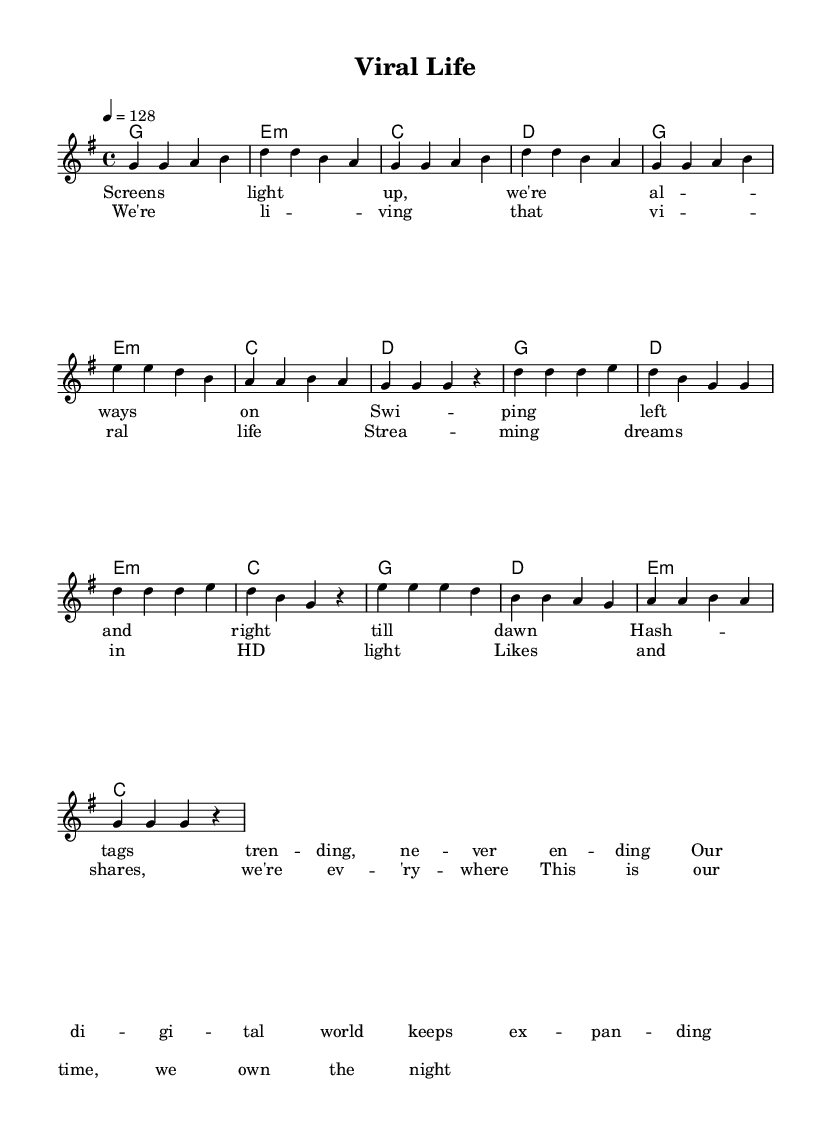What is the key signature of this music? The key signature is G major, which has one sharp (F#). This is indicated at the beginning of the score.
Answer: G major What is the time signature of this music? The time signature is 4/4, which means there are four beats in each measure and the quarter note gets one beat. This is noted at the beginning of the score.
Answer: 4/4 What is the tempo marking of this piece? The tempo marking is 128 beats per minute (BPM). This is provided right after the time signature in the global section.
Answer: 128 How many measures are in the verse? There are eight measures in the verse, as indicated by counting the individual groups of notes and bars in that section of the music.
Answer: Eight What is the first lyric of the chorus? The first lyric of the chorus is "We're living that viral life." This can be seen in the chorus lyrics section following the measure lines.
Answer: "We're living that viral life." What type of chords accompany the chorus? The chorus is accompanied by G, D, E minor, and C chords, as can be seen in the harmonies section of the score under the chorus.
Answer: G, D, E minor, C Which part of the music contains the highest notes? The highest notes are found in the chorus, with the melody reaching a peak at the note D' during the lines "We're living that viral life." This showcases a higher vocal register.
Answer: Chorus 